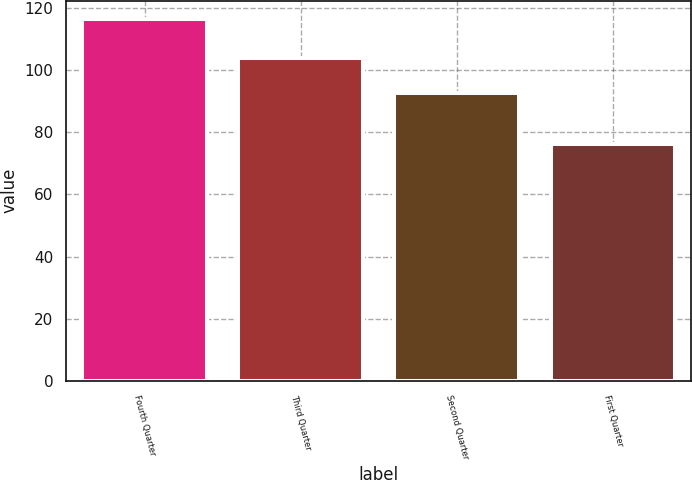Convert chart to OTSL. <chart><loc_0><loc_0><loc_500><loc_500><bar_chart><fcel>Fourth Quarter<fcel>Third Quarter<fcel>Second Quarter<fcel>First Quarter<nl><fcel>116.55<fcel>104<fcel>92.6<fcel>76.34<nl></chart> 